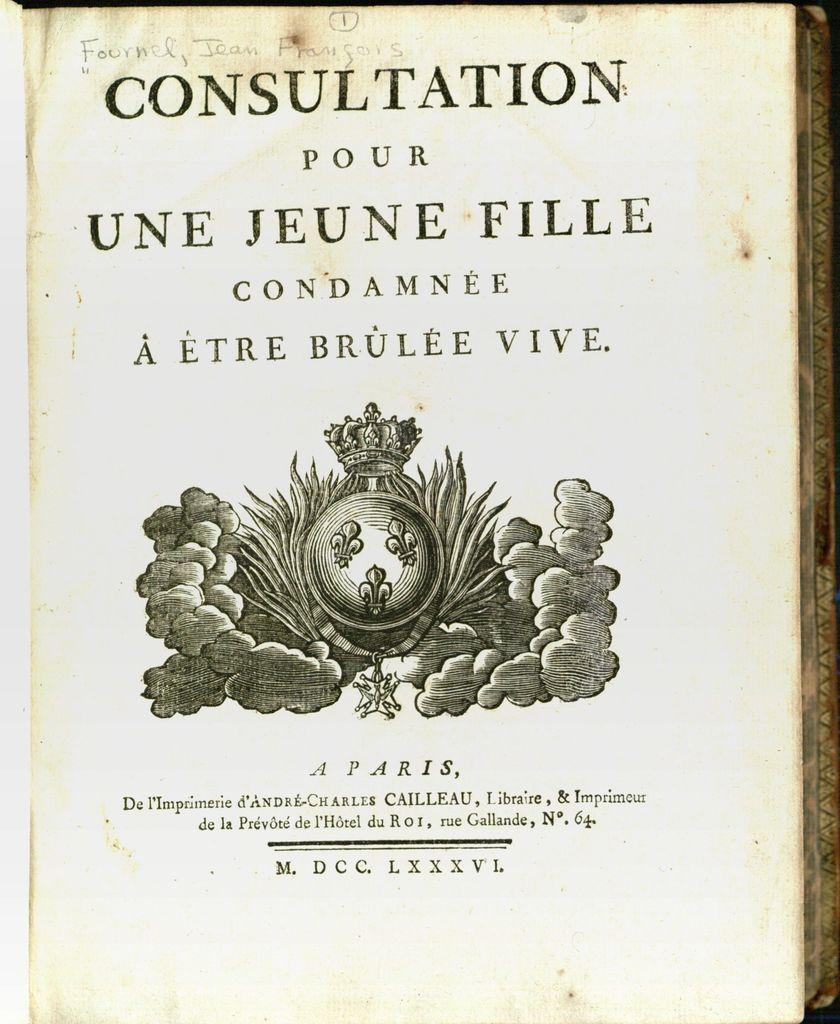Describe this image in one or two sentences. In this image there is a paper having some text and there is a painted image on it. 